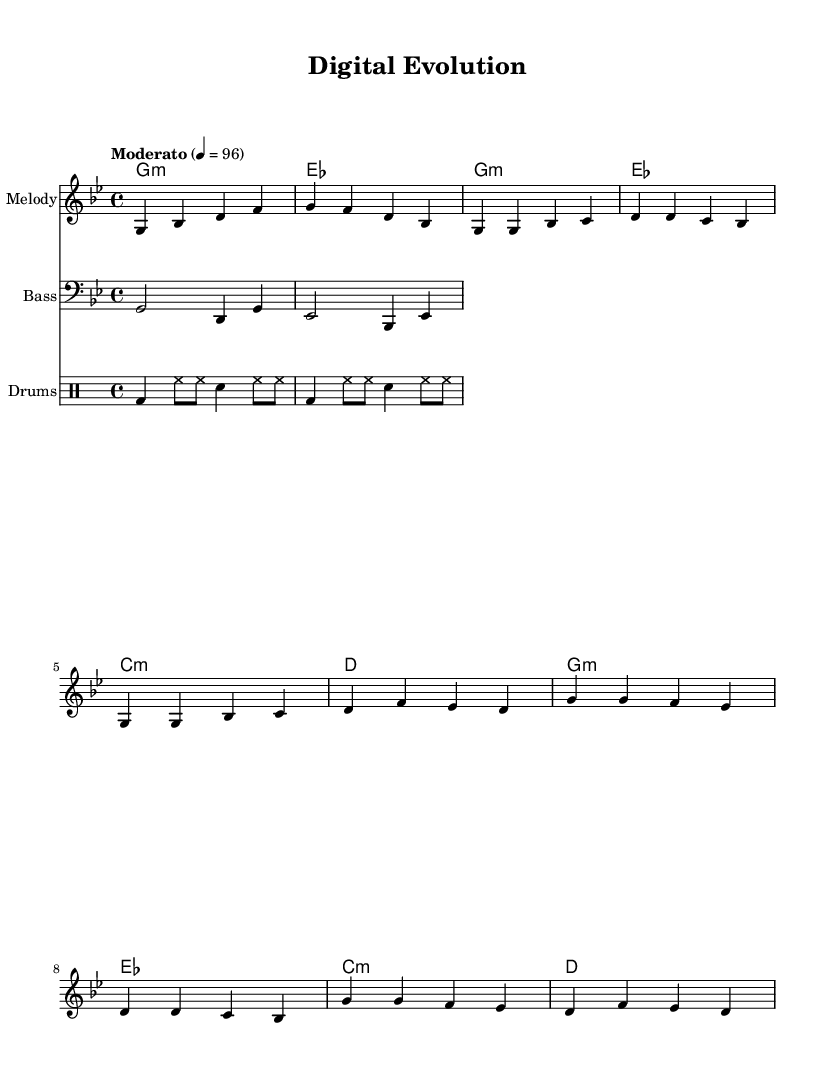What is the key signature of this music? The key signature is G minor, which has two flats (B flat and E flat). This can be identified from the key signature notation at the beginning of the sheet music.
Answer: G minor What is the time signature of this music? The time signature is 4/4, indicated at the beginning of the sheet music. This means there are four beats in a measure and the quarter note gets one beat.
Answer: 4/4 What is the tempo marking of this music? The tempo marking is "Moderato" with a tempo of 96 beats per minute, specified in the tempo indication in the score.
Answer: 96 How many measures are in the chorus section? The chorus section consists of 4 measures as can be traced in the melody and harmonies. Each line of the chorus consists of 4 individual countable measures.
Answer: 4 What type of song structure is utilized in this piece? The song structure follows a common R&B format, consisting of an intro, verse, chorus, and possibly a bridge. The presence of verses and repeated choruses is typical of Rhythm and Blues.
Answer: Verse-Chorus What is the function of the bass line in the context of this piece? The bass line primarily supports the harmonic foundation and complements the melody by establishing root notes for the chords played. It emphasizes the groove and rhythm characteristic of Rhythm and Blues music.
Answer: Harmonic foundation How does the drum pattern contribute to the overall feel of the piece? The drum pattern features a steady bass drum on beats and snare accents, providing a strong backbeat that enhances the groove. This complements the soulful feel typical of Rhythm and Blues songs.
Answer: Strong backbeat 